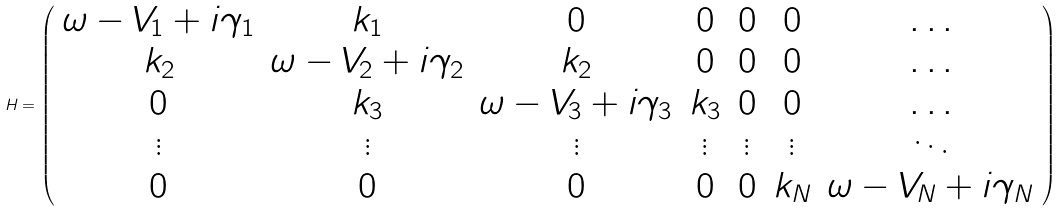Convert formula to latex. <formula><loc_0><loc_0><loc_500><loc_500>H = \left ( \begin{array} { c c c c c c c } \omega - V _ { 1 } + i \gamma _ { 1 } & k _ { 1 } & 0 & 0 & 0 & 0 & \dots \\ k _ { 2 } & \omega - V _ { 2 } + i \gamma _ { 2 } & k _ { 2 } & 0 & 0 & 0 & \dots \\ 0 & k _ { 3 } & \omega - V _ { 3 } + i \gamma _ { 3 } & k _ { 3 } & 0 & 0 & \dots \\ \vdots & \vdots & \vdots & \vdots & \vdots & \vdots & \ddots \\ 0 & 0 & 0 & 0 & 0 & k _ { N } & \omega - V _ { N } + i \gamma _ { N } \\ \end{array} \right )</formula> 